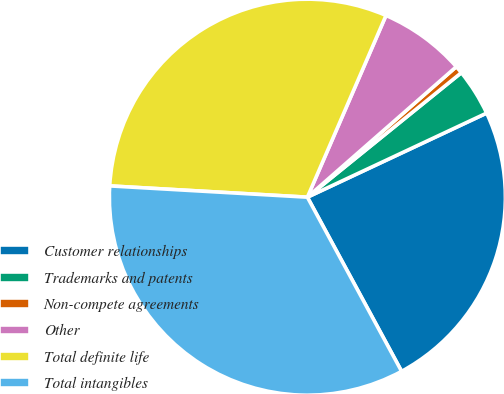Convert chart to OTSL. <chart><loc_0><loc_0><loc_500><loc_500><pie_chart><fcel>Customer relationships<fcel>Trademarks and patents<fcel>Non-compete agreements<fcel>Other<fcel>Total definite life<fcel>Total intangibles<nl><fcel>24.09%<fcel>3.84%<fcel>0.63%<fcel>7.05%<fcel>30.59%<fcel>33.8%<nl></chart> 